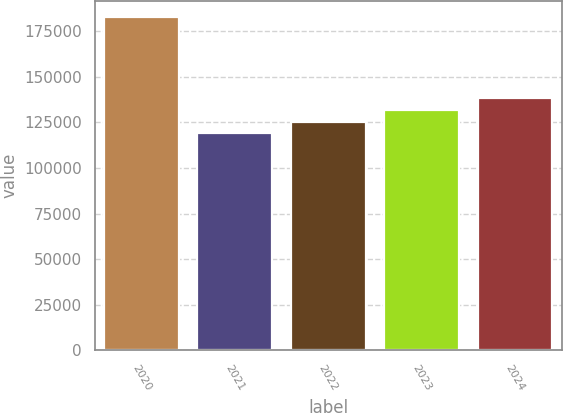Convert chart to OTSL. <chart><loc_0><loc_0><loc_500><loc_500><bar_chart><fcel>2020<fcel>2021<fcel>2022<fcel>2023<fcel>2024<nl><fcel>182583<fcel>119067<fcel>125419<fcel>131770<fcel>138122<nl></chart> 